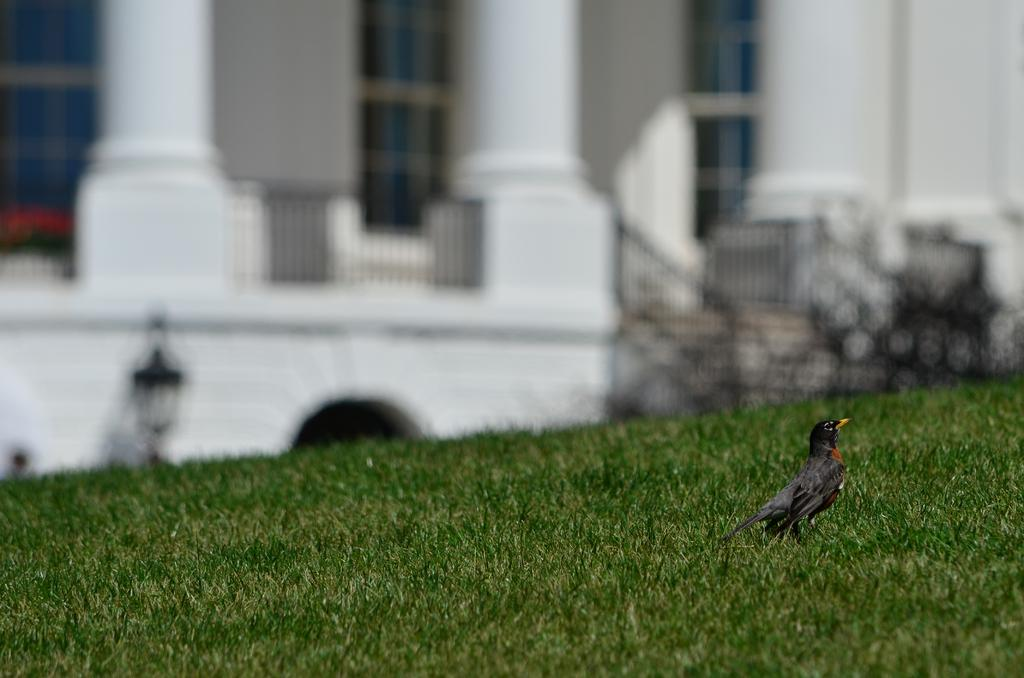What type of animal can be seen in the image? There is a bird in the image. Where is the bird located? The bird is on the grass. What can be seen in the background of the image? There is a building in the background of the image. What type of camp can be seen in the image? There is no camp present in the image; it features a bird on the grass with a building in the background. How many planes are visible in the image? There are no planes visible in the image. 